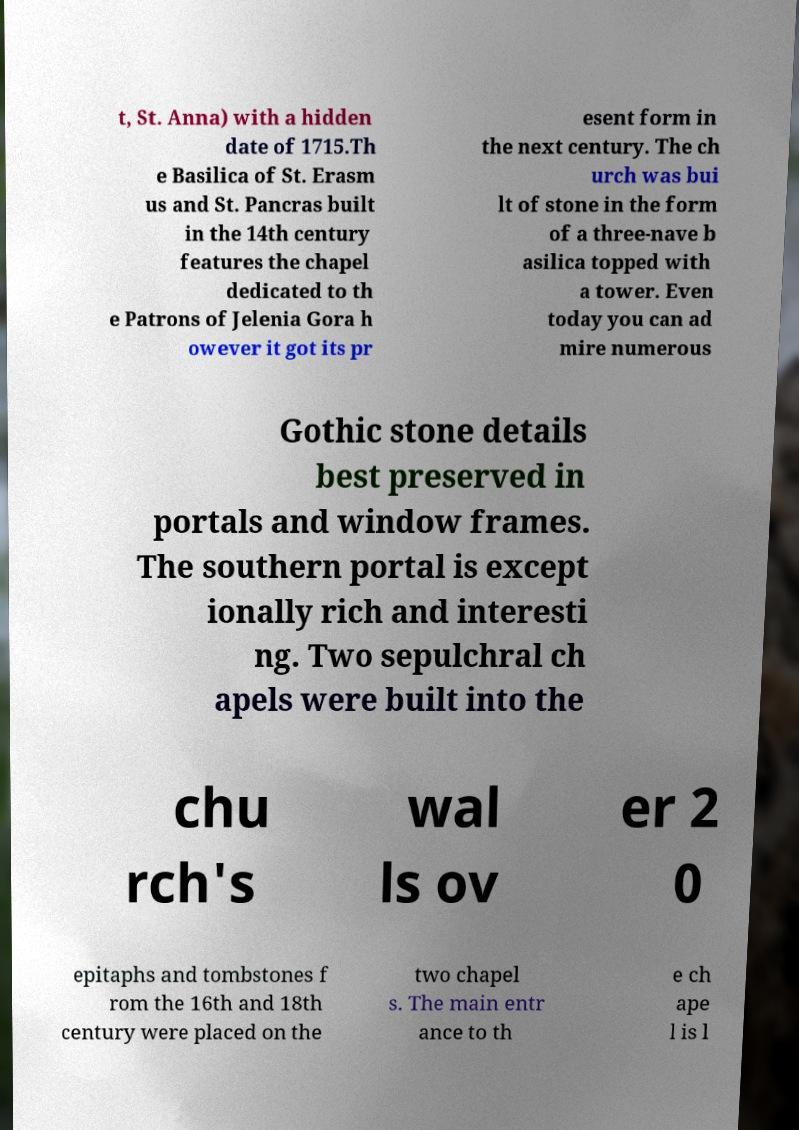Can you read and provide the text displayed in the image?This photo seems to have some interesting text. Can you extract and type it out for me? t, St. Anna) with a hidden date of 1715.Th e Basilica of St. Erasm us and St. Pancras built in the 14th century features the chapel dedicated to th e Patrons of Jelenia Gora h owever it got its pr esent form in the next century. The ch urch was bui lt of stone in the form of a three-nave b asilica topped with a tower. Even today you can ad mire numerous Gothic stone details best preserved in portals and window frames. The southern portal is except ionally rich and interesti ng. Two sepulchral ch apels were built into the chu rch's wal ls ov er 2 0 epitaphs and tombstones f rom the 16th and 18th century were placed on the two chapel s. The main entr ance to th e ch ape l is l 